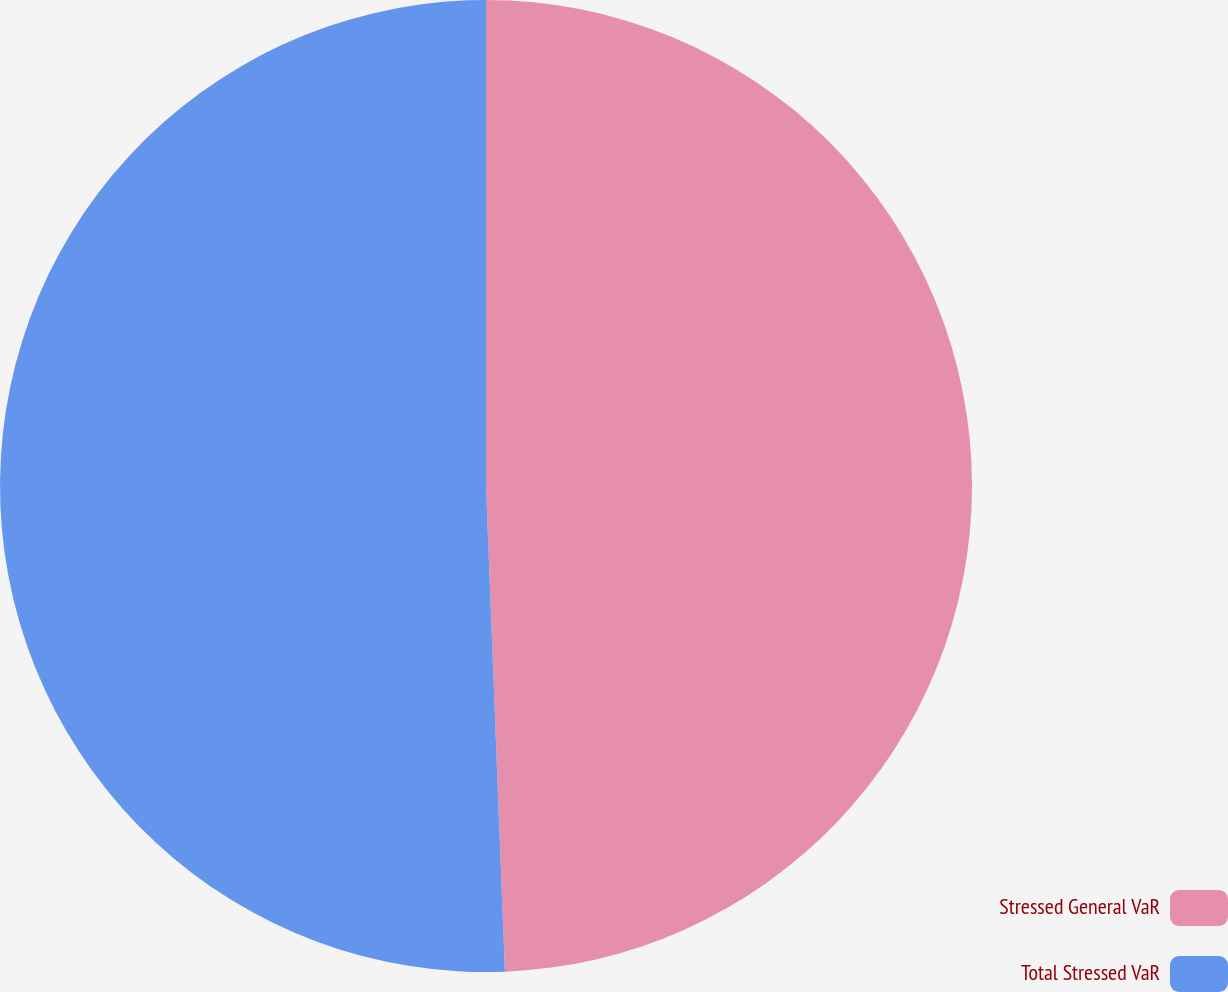<chart> <loc_0><loc_0><loc_500><loc_500><pie_chart><fcel>Stressed General VaR<fcel>Total Stressed VaR<nl><fcel>49.38%<fcel>50.62%<nl></chart> 